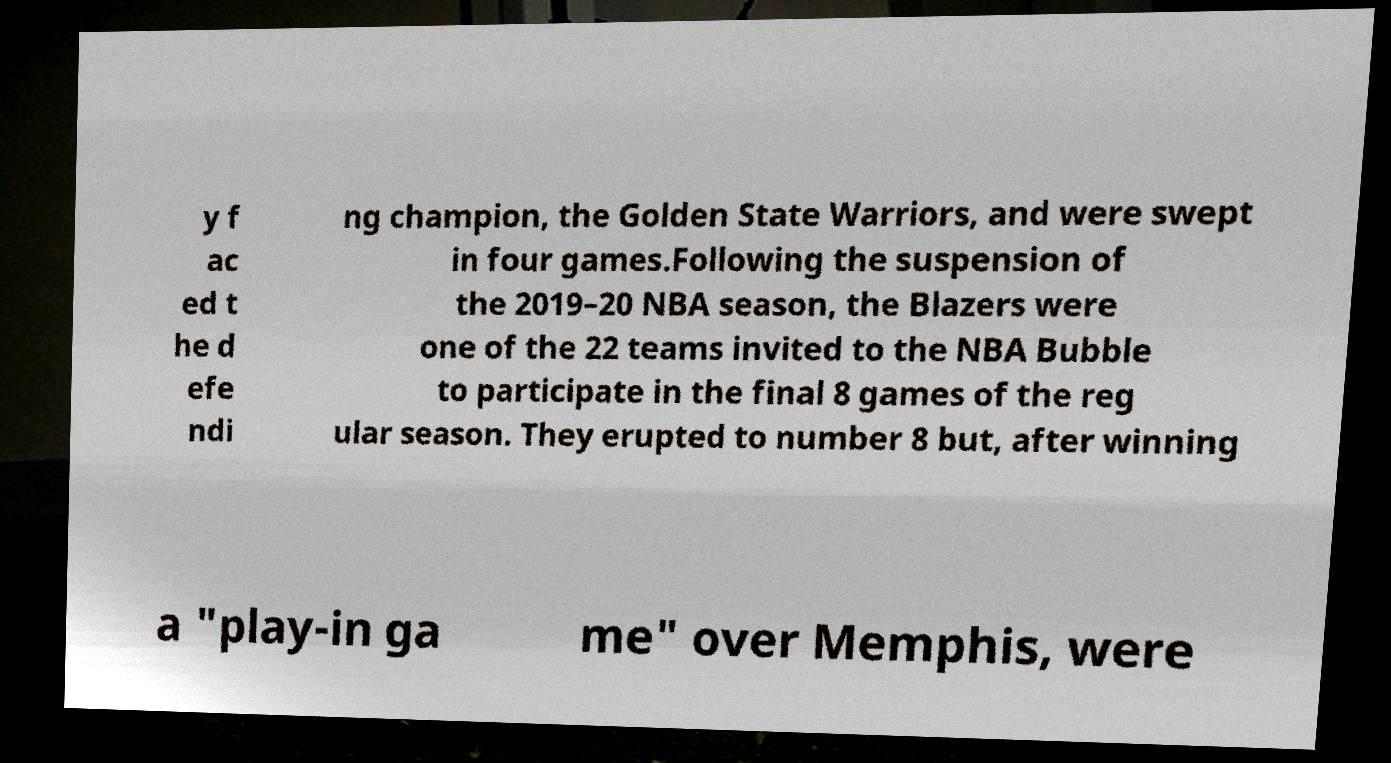Could you extract and type out the text from this image? y f ac ed t he d efe ndi ng champion, the Golden State Warriors, and were swept in four games.Following the suspension of the 2019–20 NBA season, the Blazers were one of the 22 teams invited to the NBA Bubble to participate in the final 8 games of the reg ular season. They erupted to number 8 but, after winning a "play-in ga me" over Memphis, were 